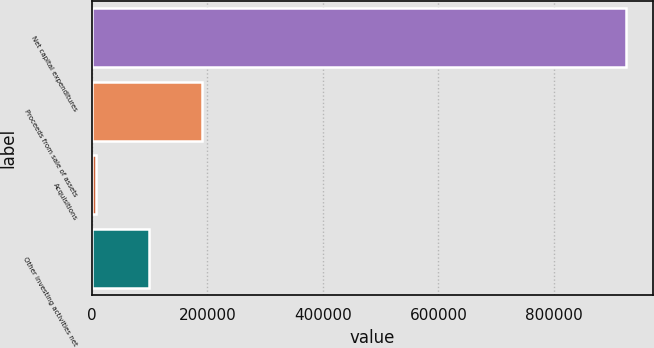Convert chart. <chart><loc_0><loc_0><loc_500><loc_500><bar_chart><fcel>Net capital expenditures<fcel>Proceeds from sale of assets<fcel>Acquisitions<fcel>Other investing activities net<nl><fcel>924858<fcel>190748<fcel>7220<fcel>98983.8<nl></chart> 